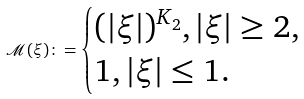Convert formula to latex. <formula><loc_0><loc_0><loc_500><loc_500>\mathcal { M } ( \xi ) \colon = \begin{cases} ( | \xi | ) ^ { K _ { 2 } } , | \xi | \geq 2 , \\ 1 , | \xi | \leq 1 . \end{cases}</formula> 